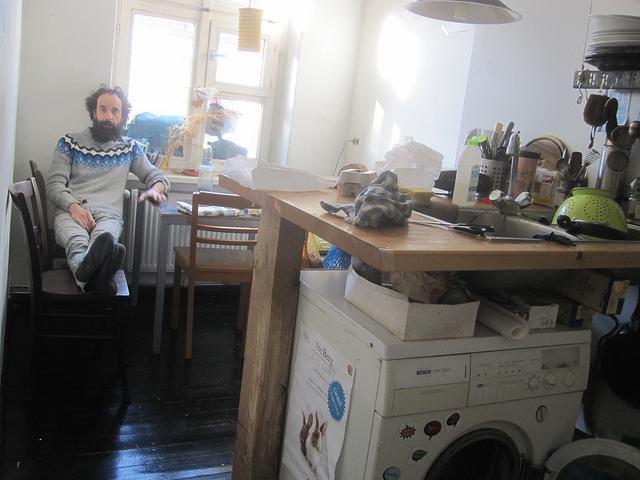What is the green object with holes in it called?
Choose the correct response and explain in the format: 'Answer: answer
Rationale: rationale.'
Options: Colander, noodle maker, cheese grater, bowl. Answer: colander.
Rationale: Colanders have holes in them to strain food. 